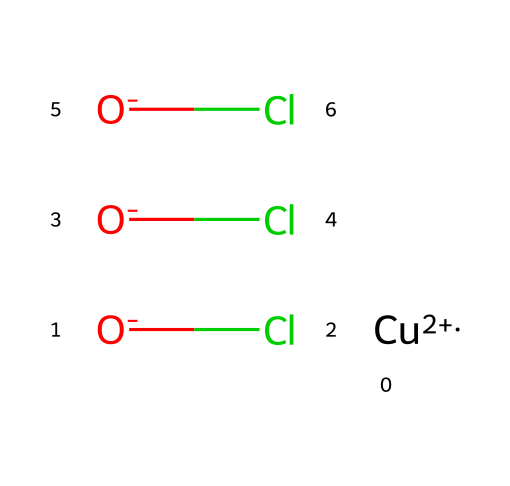What is the main metal atom in this structure? The chemical contains the atom represented by the symbol "Cu," indicating that copper is the main metal atom present.
Answer: copper How many chlorine atoms are in copper oxychloride? The SMILES representation shows three chlorine atoms, noted by the repetition of "Cl," indicating their presence in the structure.
Answer: 3 What type of chemical is copper oxychloride categorized as? Given that it is used as a fungicide, copper oxychloride is categorized as a biocide specifically designed to combat fungal growth on wood and other surfaces.
Answer: fungicide How many oxygen atoms are present in this chemical? The SMILES representation indicates that there are three "O" symbols, indicating that there are three oxygen atoms in the copper oxychloride structure.
Answer: 3 What is the oxidation state of copper in this compound? The copper is indicated with a "+2" charge, showing that the oxidation state of copper in this compound is +2.
Answer: +2 What functional groups are present in copper oxychloride? The compound itself does not have typical organic functional groups. However, it consists of metal oxyanions where "O" and "Cl" represent oxo and chloro groups interacting with copper.
Answer: metal oxyanions 